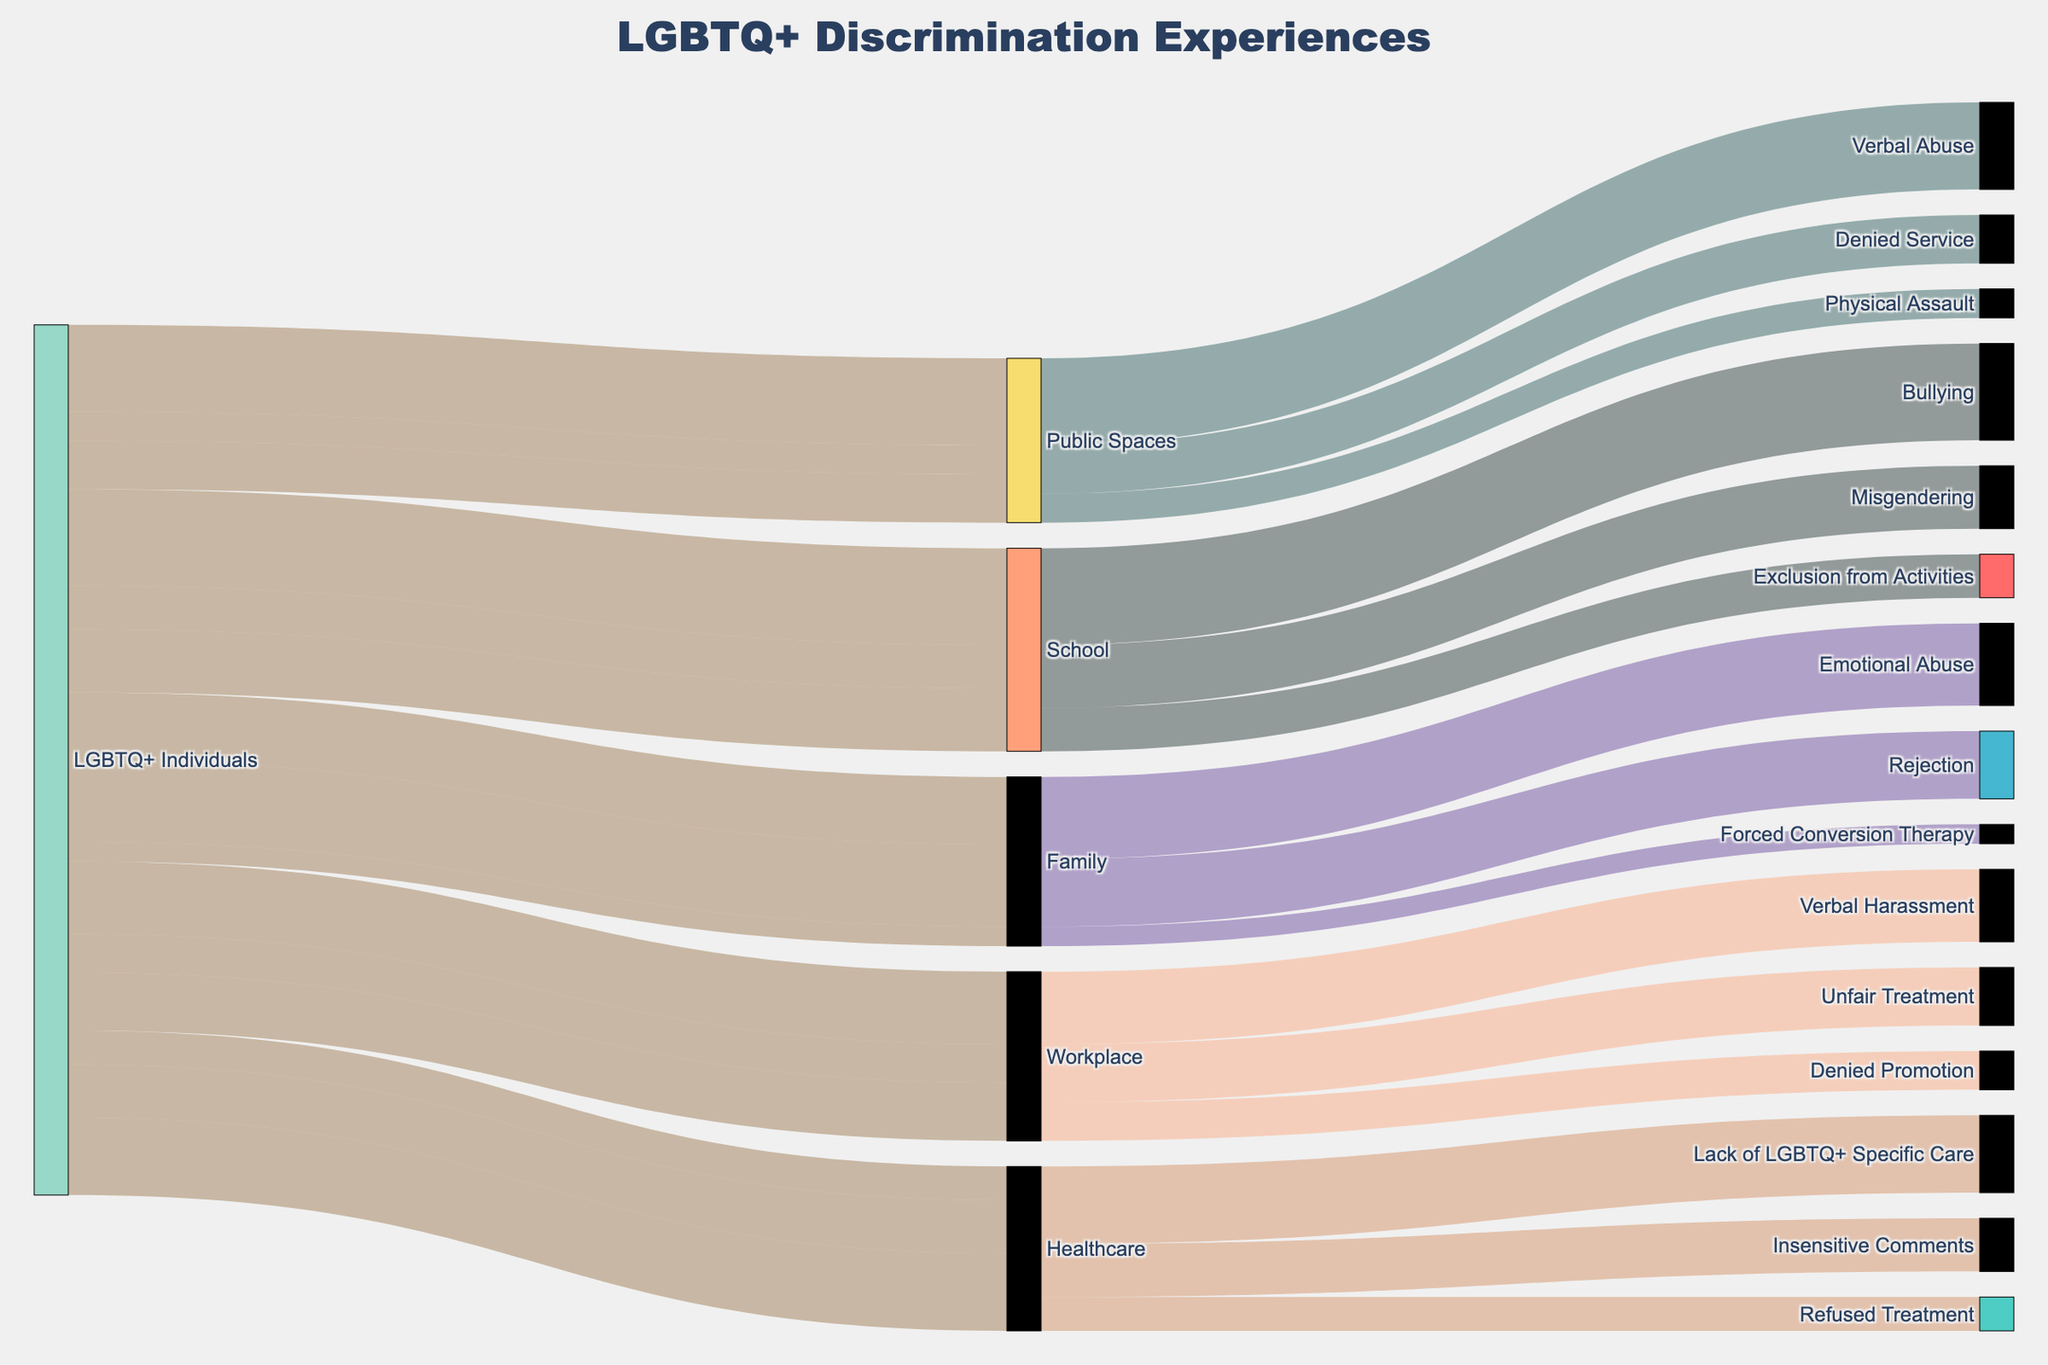Which setting has the highest count of reported discrimination? Look at the different settings (Workplace, School, Healthcare, Public Spaces, Family) and sum up their respective types of discrimination counts, then compare to find the highest total count.
Answer: School What is the total count of Verbal Harassment and Verbal Abuse across all settings? Identify the counts for 'Verbal Harassment' and 'Verbal Abuse' in their respective settings and sum them up: Verbal Harassment (Workplace, 150) and Verbal Abuse (Public Spaces, 180).
Answer: 330 Which type of discrimination is most frequently reported in Healthcare settings? Identify the types of discrimination in the Healthcare setting (Refused Treatment, Insensitive Comments, Lack of LGBTQ+ Specific Care) and compare their counts: 70, 110, 160.
Answer: Lack of LGBTQ+ Specific Care How does the count of Emotional Abuse in Family compare to Bullying in School? Compare the counts of 'Emotional Abuse' in Family (170) to 'Bullying' in School (200).
Answer: Bullying is higher by 30 What is the least reported type of discrimination across all settings? Compare the counts of all types of discrimination across the different settings to identify the one with the lowest count: Forced Conversion Therapy (Family, 40).
Answer: Forced Conversion Therapy How many total reports of discrimination are there in Public Spaces? Sum the counts of all types of discrimination reported in Public Spaces: Verbal Abuse (180), Physical Assault (60), Denied Service (100).
Answer: 340 Which setting has the smallest range of discrimination counts reported? Identify the range (difference between max and min counts) for each setting and find the smallest: 
  - Workplace: 150-80 = 70
  - School: 200-90 = 110
  - Healthcare: 160-70 = 90
  - Public Spaces: 180-60 = 120
  - Family: 170-40 = 130
Answer: Workplace, 70 Is Misgendering more frequently reported than Denied Promotion? Compare the counts of Misgendering (School, 130) to Denied Promotion (Workplace, 80).
Answer: Yes Which setting has the highest count of denial-based discrimination? Identify the total counts for 'Denied Promotion' in Workplace, 'Denied Service' in Public Spaces:
  - Workplace: Denied Promotion = 80
  - Public Spaces: Denied Service = 100 
  Public Spaces has the highest count for denial.
Answer: Public Spaces 